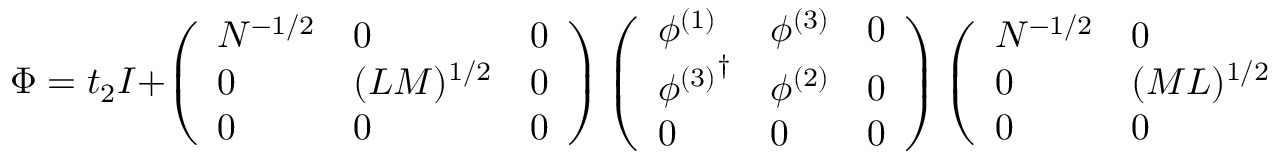<formula> <loc_0><loc_0><loc_500><loc_500>\Phi = t _ { 2 } I + \left ( \begin{array} { l l l } { { N ^ { - 1 / 2 } } } & { 0 } & { 0 } \\ { 0 } & { { ( L M ) ^ { 1 / 2 } } } & { 0 } \\ { 0 } & { 0 } & { 0 } \end{array} \right ) \left ( \begin{array} { l l l } { { \phi ^ { ( 1 ) } } } & { { \phi ^ { ( 3 ) } } } & { 0 } \\ { { { \phi ^ { ( 3 ) } } ^ { \dagger } } } & { { \phi ^ { ( 2 ) } } } & { 0 } \\ { 0 } & { 0 } & { 0 } \end{array} \right ) \left ( \begin{array} { l l l } { { N ^ { - 1 / 2 } } } & { 0 } & { 0 } \\ { 0 } & { { ( M L ) ^ { 1 / 2 } } } & { 0 } \\ { 0 } & { 0 } & { 0 } \end{array} \right )</formula> 